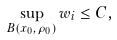Convert formula to latex. <formula><loc_0><loc_0><loc_500><loc_500>\sup _ { B ( x _ { 0 } , \rho _ { 0 } ) } w _ { i } \leq C ,</formula> 